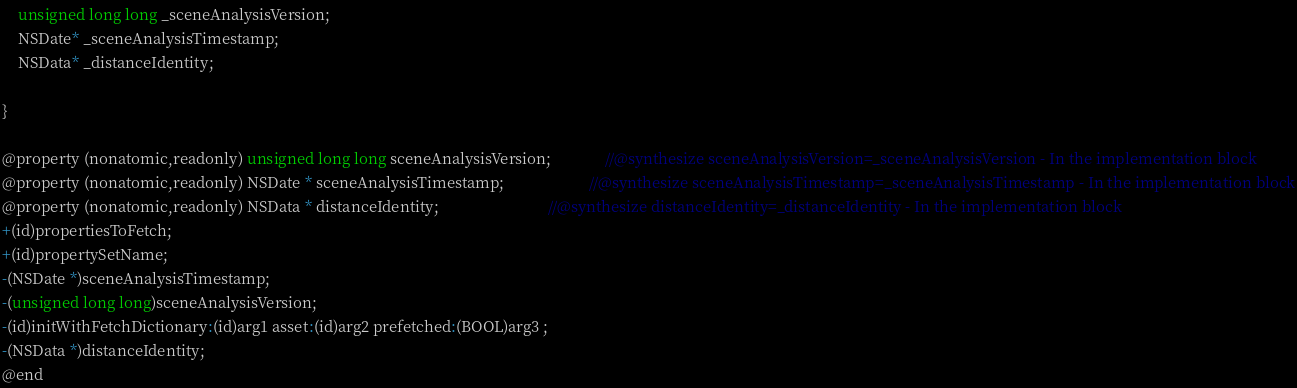Convert code to text. <code><loc_0><loc_0><loc_500><loc_500><_C_>
	unsigned long long _sceneAnalysisVersion;
	NSDate* _sceneAnalysisTimestamp;
	NSData* _distanceIdentity;

}

@property (nonatomic,readonly) unsigned long long sceneAnalysisVersion;              //@synthesize sceneAnalysisVersion=_sceneAnalysisVersion - In the implementation block
@property (nonatomic,readonly) NSDate * sceneAnalysisTimestamp;                      //@synthesize sceneAnalysisTimestamp=_sceneAnalysisTimestamp - In the implementation block
@property (nonatomic,readonly) NSData * distanceIdentity;                            //@synthesize distanceIdentity=_distanceIdentity - In the implementation block
+(id)propertiesToFetch;
+(id)propertySetName;
-(NSDate *)sceneAnalysisTimestamp;
-(unsigned long long)sceneAnalysisVersion;
-(id)initWithFetchDictionary:(id)arg1 asset:(id)arg2 prefetched:(BOOL)arg3 ;
-(NSData *)distanceIdentity;
@end

</code> 